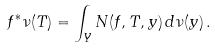<formula> <loc_0><loc_0><loc_500><loc_500>f ^ { * } \nu ( T ) = \int _ { Y } N ( f , T , y ) \, d \nu ( y ) \, .</formula> 